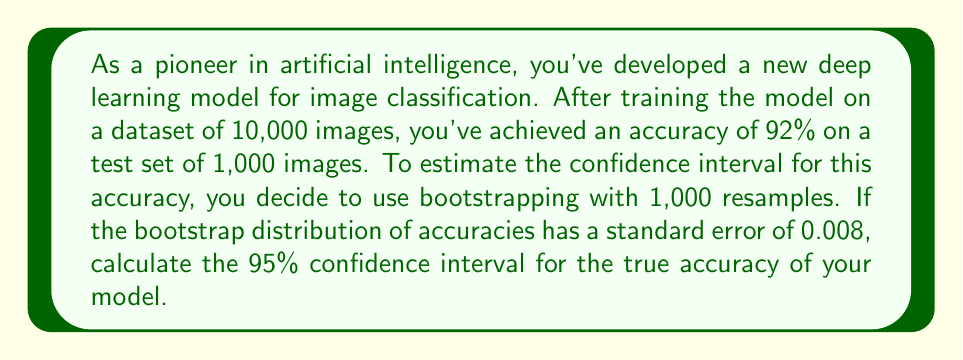What is the answer to this math problem? To solve this problem, we'll follow these steps:

1. Identify the point estimate of accuracy: 92% or 0.92
2. Recognize the standard error from bootstrapping: 0.008
3. Calculate the margin of error for a 95% confidence interval
4. Compute the lower and upper bounds of the confidence interval

Step 1: The point estimate is already given as 92% or 0.92.

Step 2: The standard error from bootstrapping is given as 0.008.

Step 3: For a 95% confidence interval, we use the z-score of 1.96 (assuming a normal distribution of the bootstrap samples). The margin of error is calculated as:

$$ \text{Margin of Error} = z \times \text{Standard Error} $$
$$ \text{Margin of Error} = 1.96 \times 0.008 = 0.01568 $$

Step 4: The confidence interval is calculated by adding and subtracting the margin of error from the point estimate:

$$ \text{Lower Bound} = \text{Point Estimate} - \text{Margin of Error} $$
$$ \text{Lower Bound} = 0.92 - 0.01568 = 0.90432 $$

$$ \text{Upper Bound} = \text{Point Estimate} + \text{Margin of Error} $$
$$ \text{Upper Bound} = 0.92 + 0.01568 = 0.93568 $$

Therefore, the 95% confidence interval for the true accuracy of the model is (0.90432, 0.93568) or approximately (90.43%, 93.57%).
Answer: The 95% confidence interval for the true accuracy of the deep learning model is (90.43%, 93.57%). 